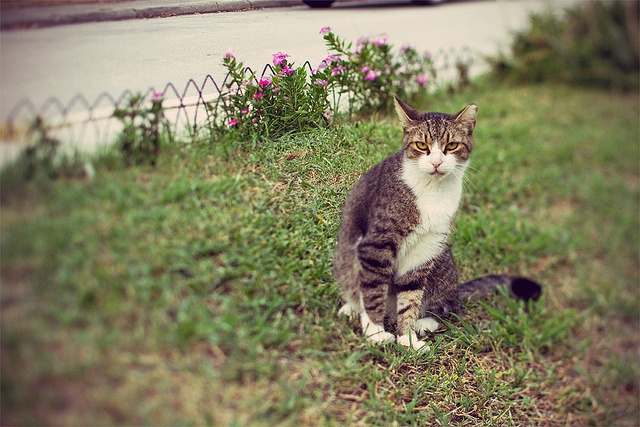Describe the objects in this image and their specific colors. I can see a cat in purple, gray, black, and beige tones in this image. 